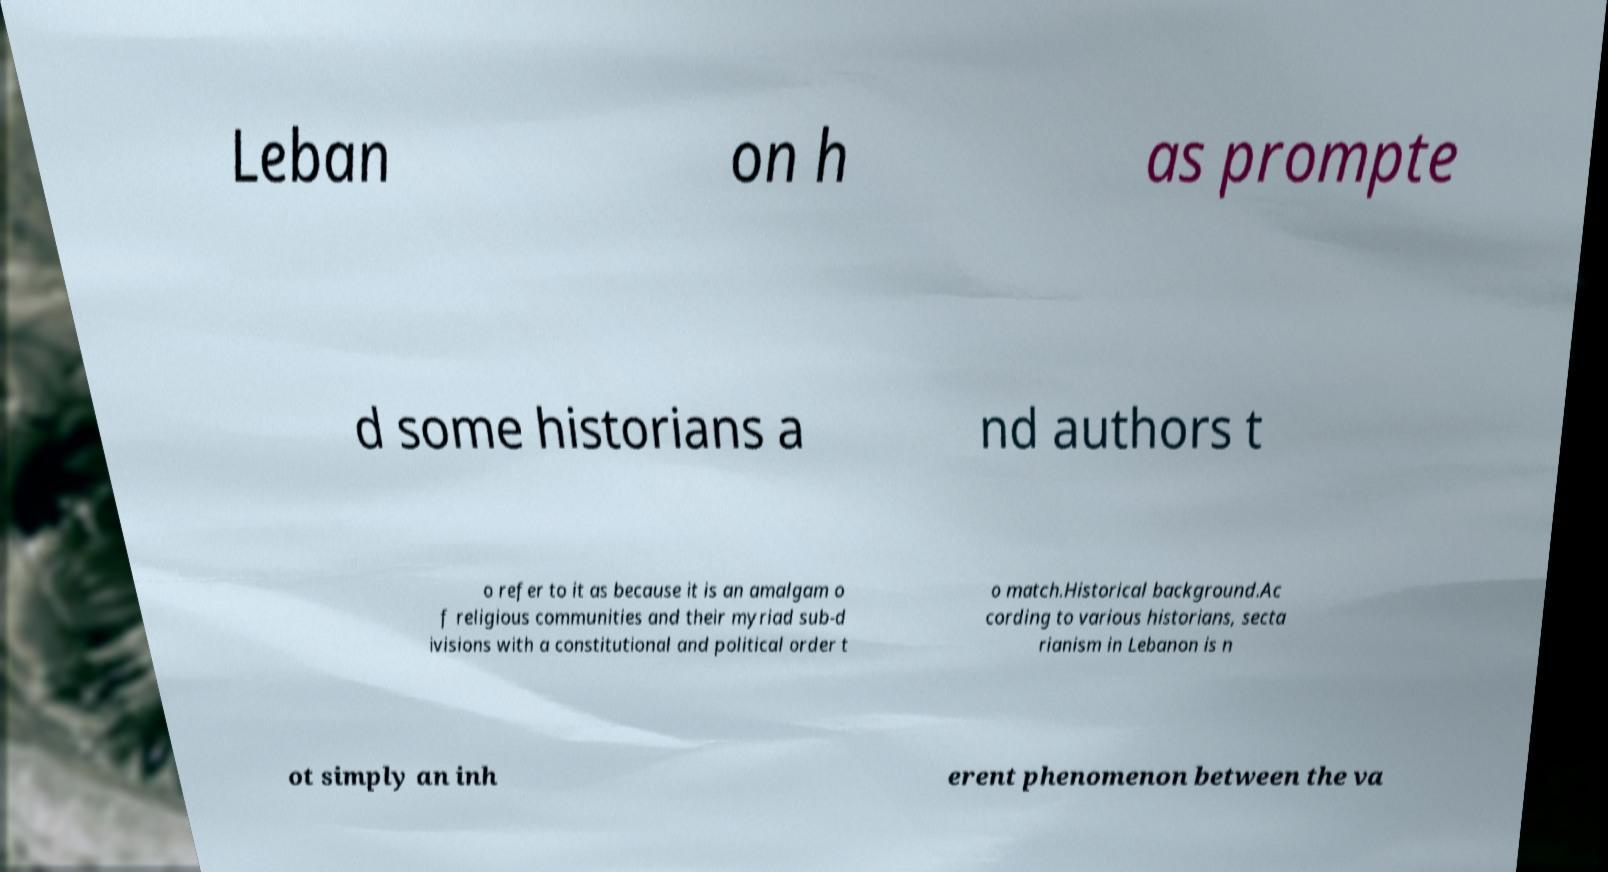Please read and relay the text visible in this image. What does it say? Leban on h as prompte d some historians a nd authors t o refer to it as because it is an amalgam o f religious communities and their myriad sub-d ivisions with a constitutional and political order t o match.Historical background.Ac cording to various historians, secta rianism in Lebanon is n ot simply an inh erent phenomenon between the va 